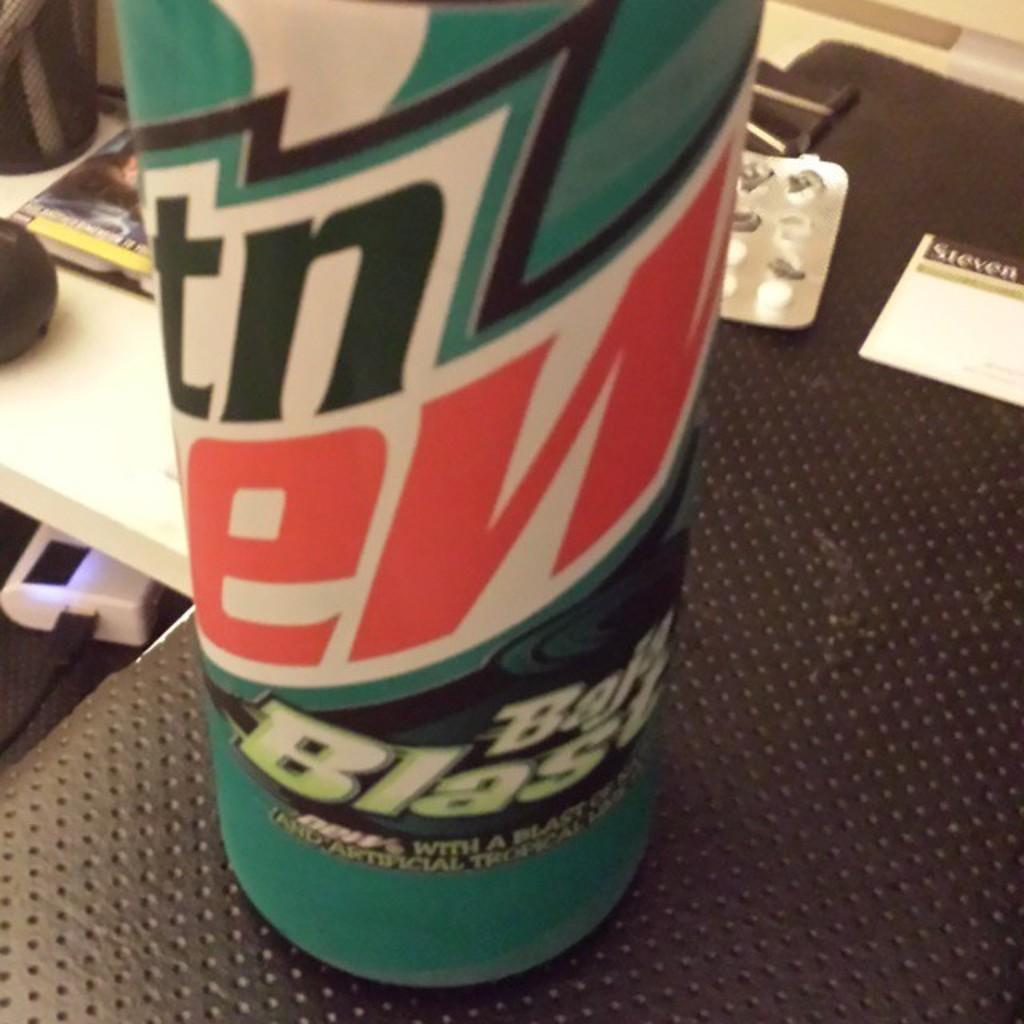<image>
Provide a brief description of the given image. A can of soda is labelled as "Baja Blast." 